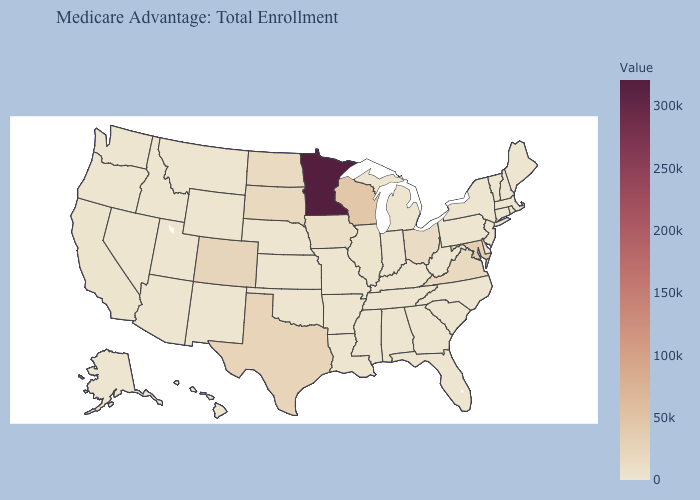Which states have the lowest value in the Northeast?
Be succinct. Connecticut, Massachusetts, Maine, New Hampshire, New Jersey, Pennsylvania, Rhode Island, Vermont. Which states hav the highest value in the West?
Be succinct. Colorado. Does Arkansas have the highest value in the South?
Concise answer only. No. Does Minnesota have the highest value in the USA?
Write a very short answer. Yes. Among the states that border Connecticut , does New York have the highest value?
Answer briefly. Yes. 